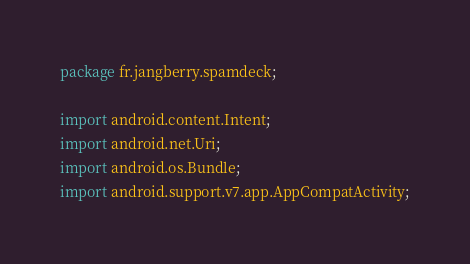Convert code to text. <code><loc_0><loc_0><loc_500><loc_500><_Java_>package fr.jangberry.spamdeck;

import android.content.Intent;
import android.net.Uri;
import android.os.Bundle;
import android.support.v7.app.AppCompatActivity;</code> 